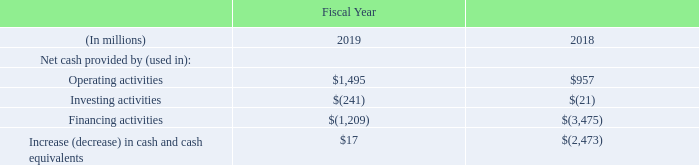Cash flows
The following table summarizes our cash flow activities in fiscal 2019 compared to fiscal 2018.
Our cash flow activities in fiscal 2018 compared to fiscal 2017 were discussed under Liquidity, Capital Resources and Cash Requirement in Item 7. Management’s Discussion and Analysis of Financial Condition and Results of Operations included in our Annual Report on Form 10-K for the fiscal year ended March 30, 2018.
What does the table show? Cash flow activities in fiscal 2019 compared to fiscal 2018. What is date of the end of fiscal 2018? March 30, 2018. What is the Net cash provided by operating activities in fiscal 2019?
Answer scale should be: million. $1,495. What is the total Net cash provided by Operating activities for fiscal 2019 and 2018? 
Answer scale should be: million. 1,495+957
Answer: 2452. What is the average Net cash provided by for operating activities for fiscal 2019 and 2018?
Answer scale should be: million. (1,495+957)/2
Answer: 1226. What is the average Net cash used in for Financing activities for fiscal 2019 and 2018?
Answer scale should be: million. (1,209+3,475)/2
Answer: 2342. 